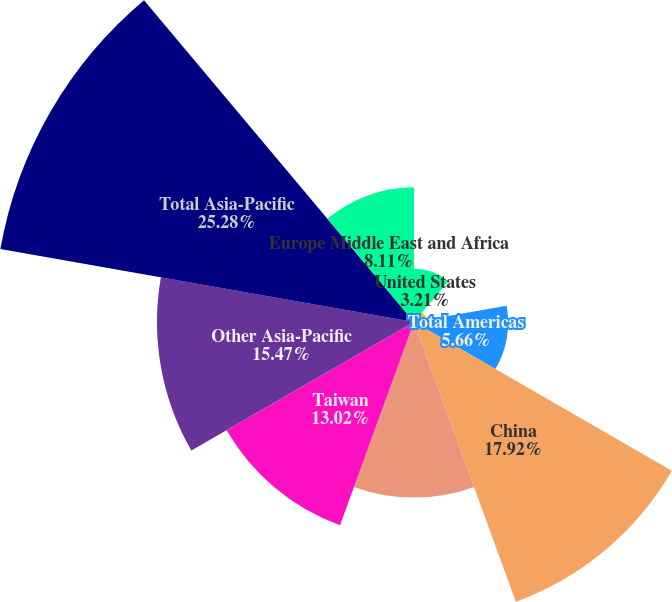Convert chart. <chart><loc_0><loc_0><loc_500><loc_500><pie_chart><fcel>United States<fcel>Other Americas<fcel>Total Americas<fcel>China<fcel>South Korea<fcel>Taiwan<fcel>Other Asia-Pacific<fcel>Total Asia-Pacific<fcel>Europe Middle East and Africa<nl><fcel>3.21%<fcel>0.76%<fcel>5.66%<fcel>17.92%<fcel>10.57%<fcel>13.02%<fcel>15.47%<fcel>25.28%<fcel>8.11%<nl></chart> 